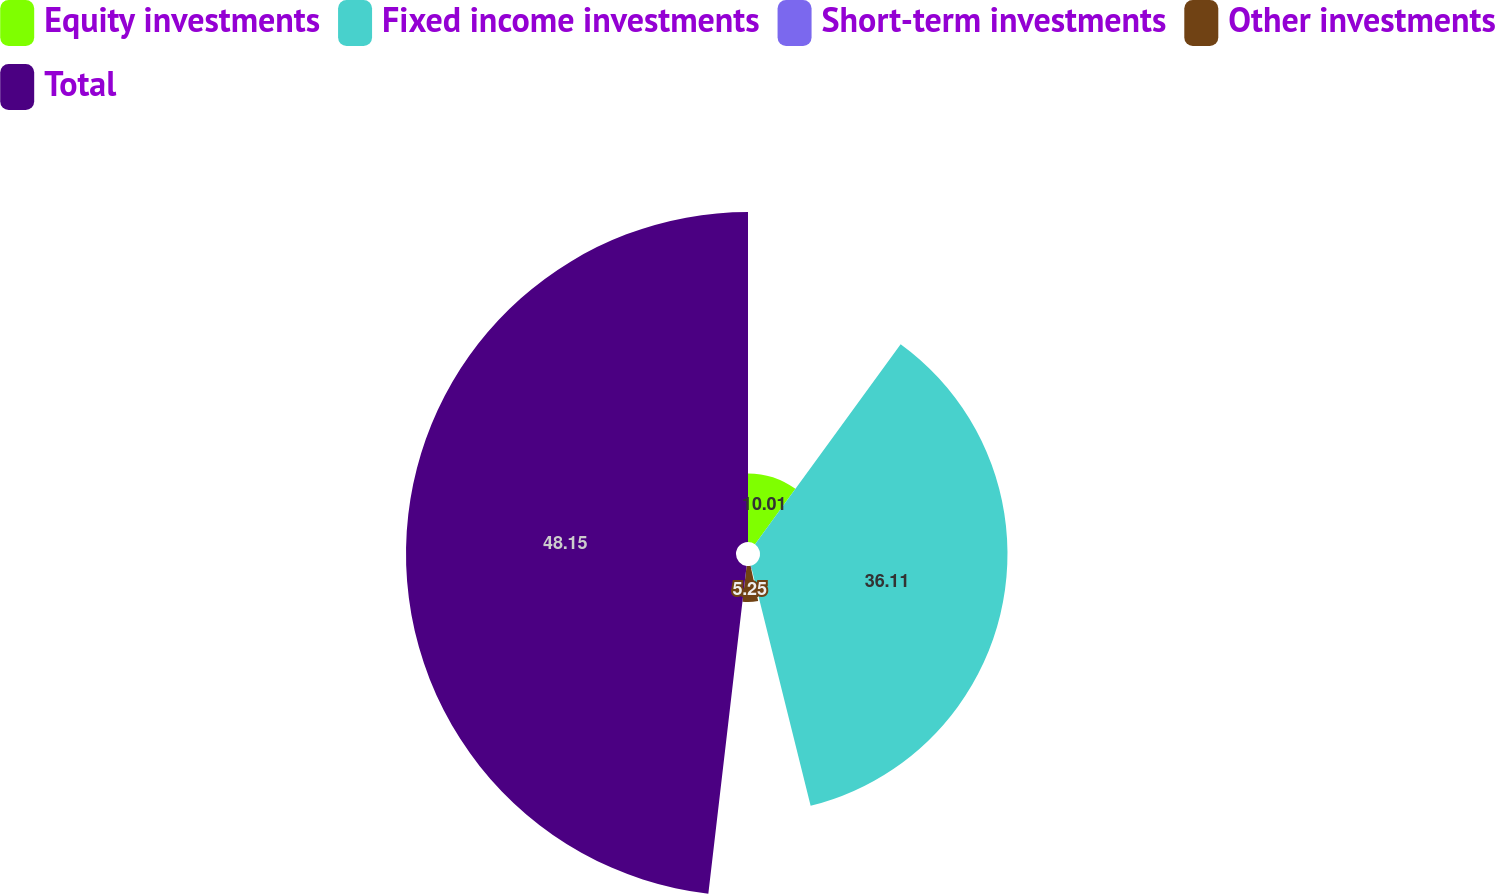<chart> <loc_0><loc_0><loc_500><loc_500><pie_chart><fcel>Equity investments<fcel>Fixed income investments<fcel>Short-term investments<fcel>Other investments<fcel>Total<nl><fcel>10.01%<fcel>36.11%<fcel>0.48%<fcel>5.25%<fcel>48.15%<nl></chart> 